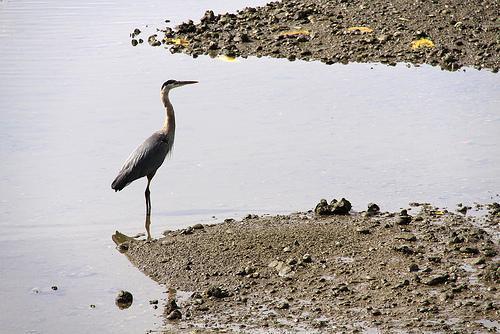How many birds are there?
Give a very brief answer. 1. 